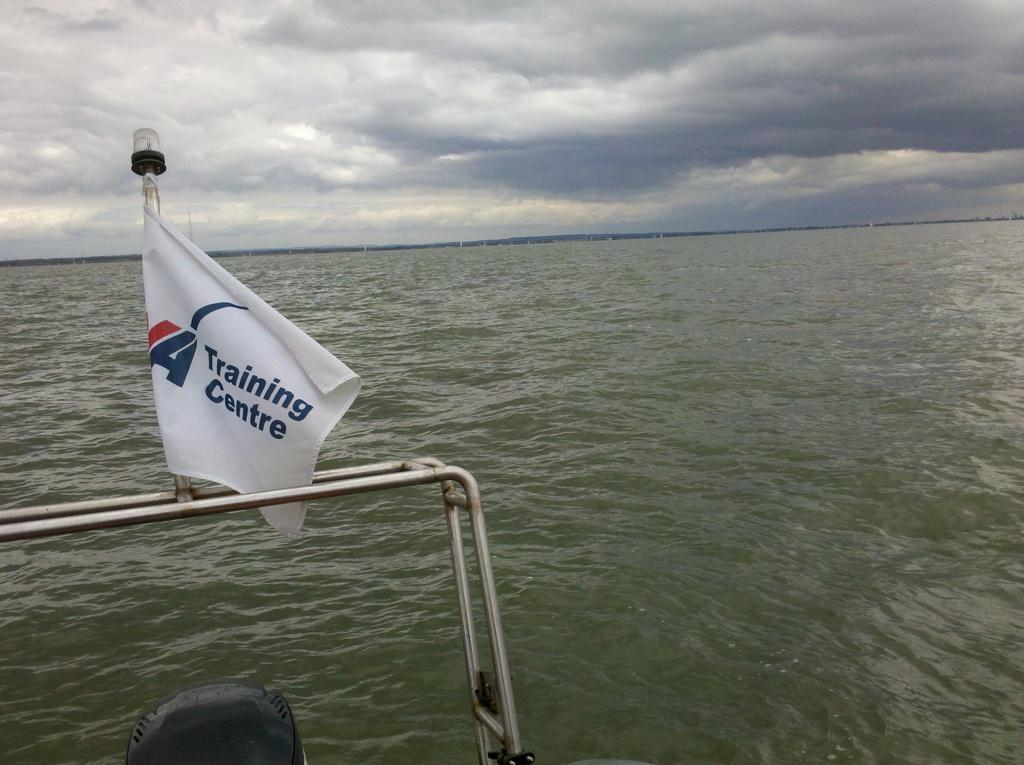What is attached to the metal rod in the image? There is a flag on a metal rod in the image. What can be seen in the ocean in the image? There is an object in the ocean in the image. What is visible in the sky at the top of the image? There are clouds visible in the sky at the top of the image. What type of muscle is being exercised by the chicken in the image? There is no chicken present in the image, so it is not possible to determine what type of muscle might be exercised. 